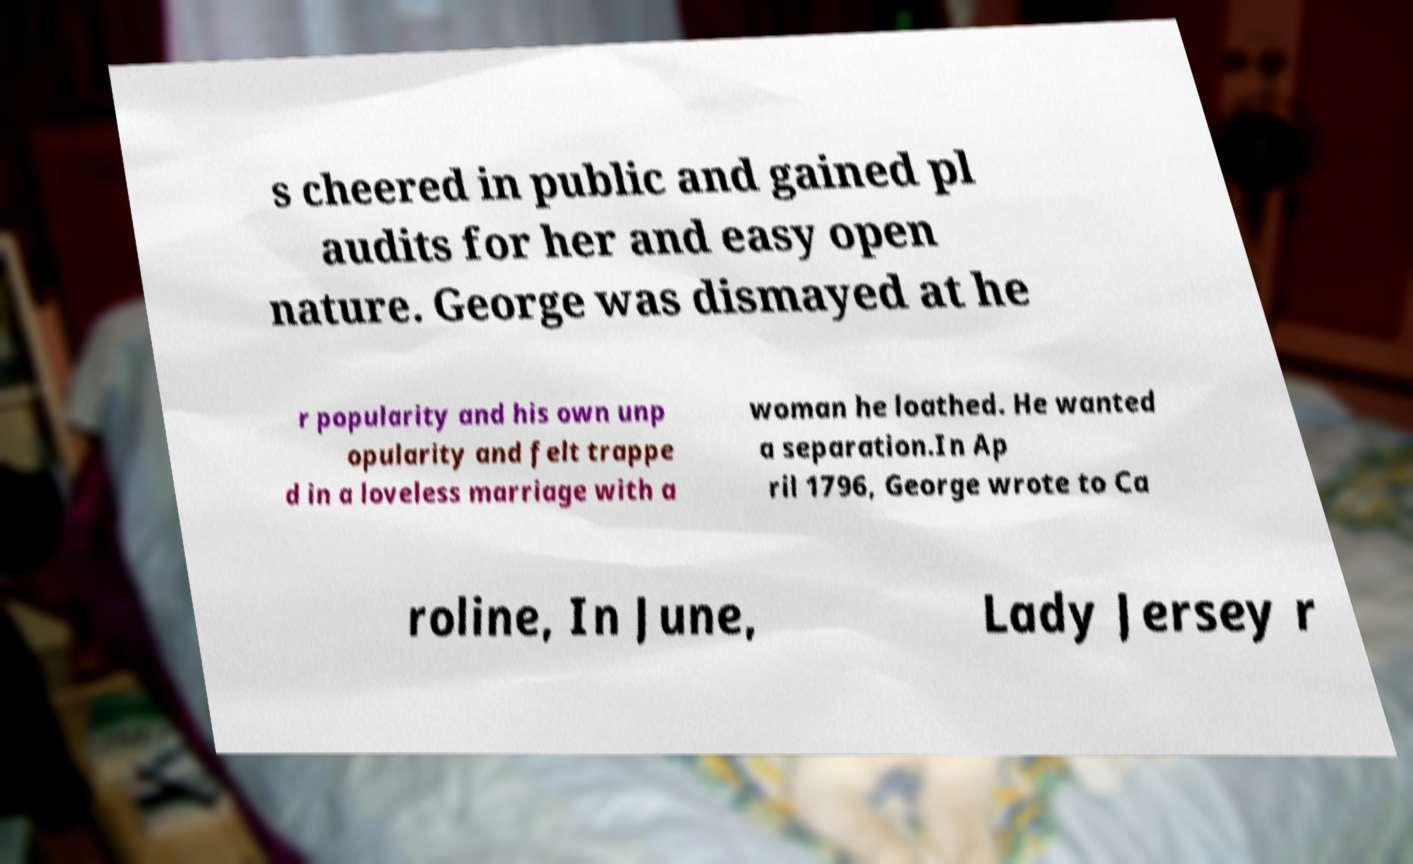Please identify and transcribe the text found in this image. s cheered in public and gained pl audits for her and easy open nature. George was dismayed at he r popularity and his own unp opularity and felt trappe d in a loveless marriage with a woman he loathed. He wanted a separation.In Ap ril 1796, George wrote to Ca roline, In June, Lady Jersey r 